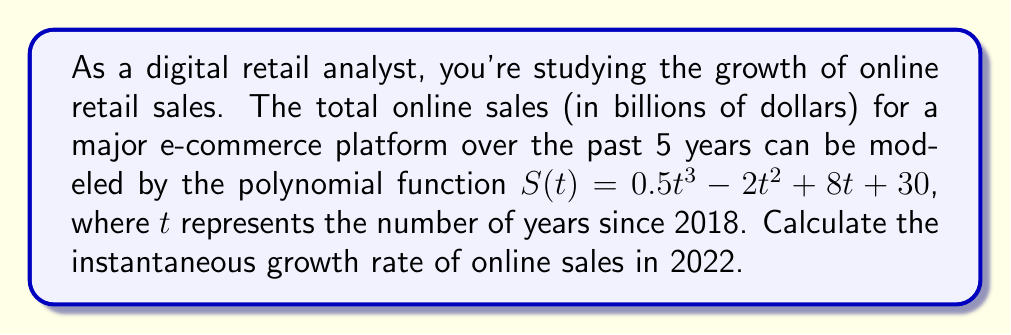Teach me how to tackle this problem. To solve this problem, we need to follow these steps:

1) The instantaneous growth rate is given by the derivative of the sales function $S(t)$ at the point in question.

2) First, let's find the derivative of $S(t)$:
   $$S'(t) = 1.5t^2 - 4t + 8$$

3) We need to calculate this for 2022, which is 4 years after 2018. So, we need to evaluate $S'(4)$:

   $$S'(4) = 1.5(4)^2 - 4(4) + 8$$
   $$= 1.5(16) - 16 + 8$$
   $$= 24 - 16 + 8$$
   $$= 16$$

4) The units of the growth rate will be billions of dollars per year, as the original function was in billions of dollars and t was in years.

Therefore, the instantaneous growth rate in 2022 is 16 billion dollars per year.
Answer: $16 billion/year 